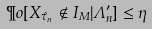Convert formula to latex. <formula><loc_0><loc_0><loc_500><loc_500>\P o [ X _ { \hat { \tau } _ { n } } \notin I _ { M } | \Lambda ^ { \prime } _ { n } ] \leq \eta</formula> 